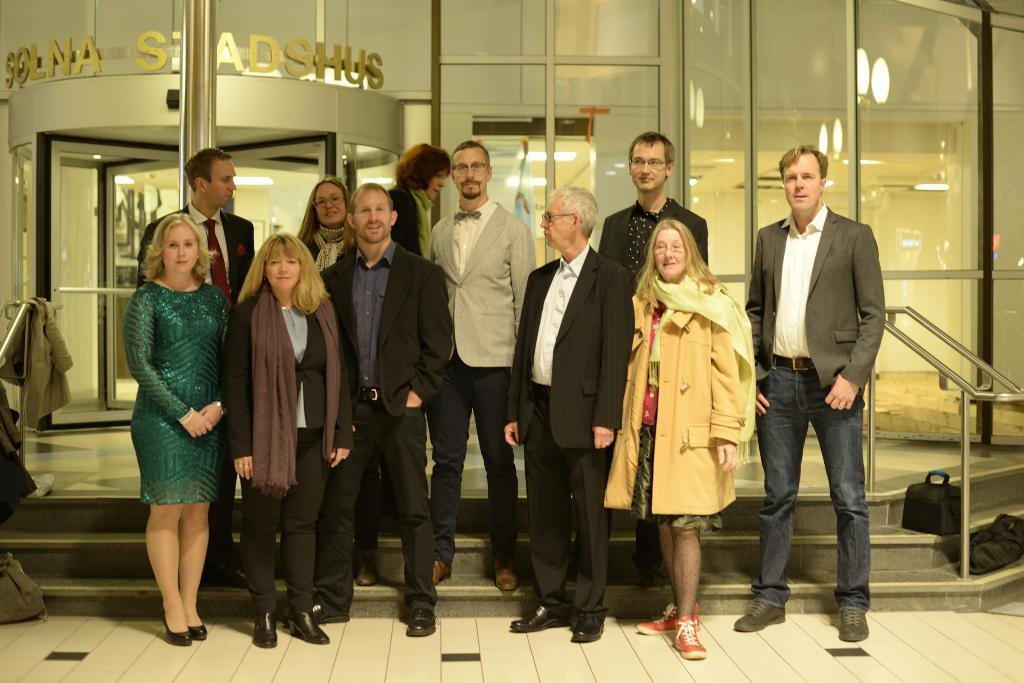What can be seen in the image involving people? There are people standing in the image. What objects are present that might be used for carrying items? There are bags in the image. What type of items can be seen related to clothing? There are clothes in the image. What architectural features are visible in the image? There are railings and steps in the image. What material is present that allows for transparency? There is glass in the image. What can be seen through the glass? Lights and text are visible through the glass. How many cats are visible on the steps in the image? There are no cats present in the image; it features people, bags, clothes, railings, steps, glass, lights, and text. What word is written on the railings in the image? There is no word written on the railings in the image; only the railings themselves are visible. 